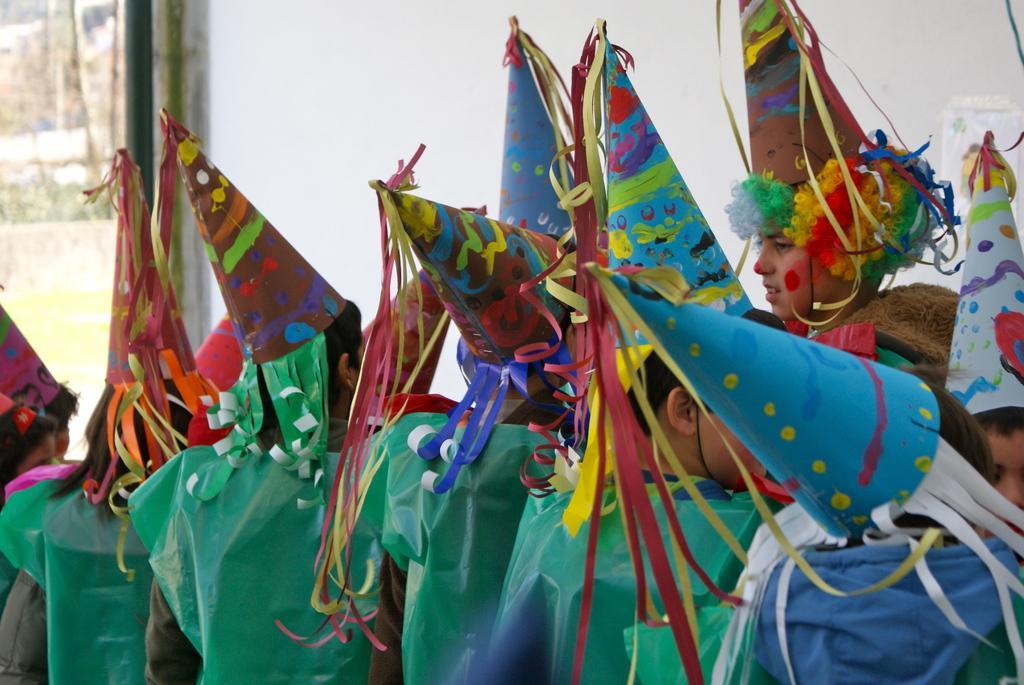Please provide a concise description of this image. In the middle of the image few people are standing and watching. Behind them there is wall. 